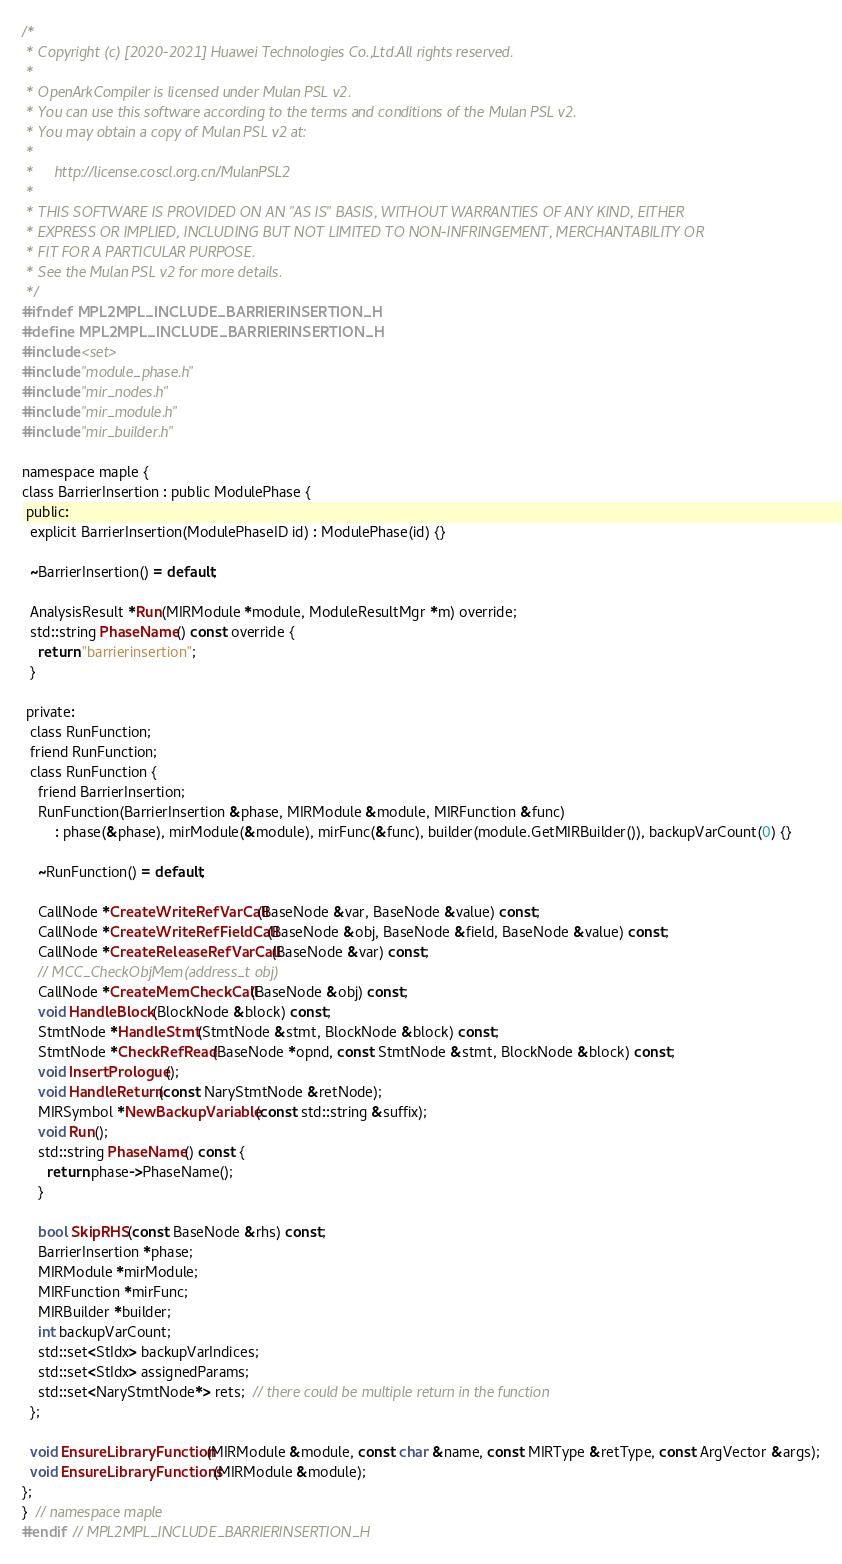<code> <loc_0><loc_0><loc_500><loc_500><_C_>/*
 * Copyright (c) [2020-2021] Huawei Technologies Co.,Ltd.All rights reserved.
 *
 * OpenArkCompiler is licensed under Mulan PSL v2.
 * You can use this software according to the terms and conditions of the Mulan PSL v2.
 * You may obtain a copy of Mulan PSL v2 at:
 *
 *     http://license.coscl.org.cn/MulanPSL2
 *
 * THIS SOFTWARE IS PROVIDED ON AN "AS IS" BASIS, WITHOUT WARRANTIES OF ANY KIND, EITHER
 * EXPRESS OR IMPLIED, INCLUDING BUT NOT LIMITED TO NON-INFRINGEMENT, MERCHANTABILITY OR
 * FIT FOR A PARTICULAR PURPOSE.
 * See the Mulan PSL v2 for more details.
 */
#ifndef MPL2MPL_INCLUDE_BARRIERINSERTION_H
#define MPL2MPL_INCLUDE_BARRIERINSERTION_H
#include <set>
#include "module_phase.h"
#include "mir_nodes.h"
#include "mir_module.h"
#include "mir_builder.h"

namespace maple {
class BarrierInsertion : public ModulePhase {
 public:
  explicit BarrierInsertion(ModulePhaseID id) : ModulePhase(id) {}

  ~BarrierInsertion() = default;

  AnalysisResult *Run(MIRModule *module, ModuleResultMgr *m) override;
  std::string PhaseName() const override {
    return "barrierinsertion";
  }

 private:
  class RunFunction;
  friend RunFunction;
  class RunFunction {
    friend BarrierInsertion;
    RunFunction(BarrierInsertion &phase, MIRModule &module, MIRFunction &func)
        : phase(&phase), mirModule(&module), mirFunc(&func), builder(module.GetMIRBuilder()), backupVarCount(0) {}

    ~RunFunction() = default;

    CallNode *CreateWriteRefVarCall(BaseNode &var, BaseNode &value) const;
    CallNode *CreateWriteRefFieldCall(BaseNode &obj, BaseNode &field, BaseNode &value) const;
    CallNode *CreateReleaseRefVarCall(BaseNode &var) const;
    // MCC_CheckObjMem(address_t obj)
    CallNode *CreateMemCheckCall(BaseNode &obj) const;
    void HandleBlock(BlockNode &block) const;
    StmtNode *HandleStmt(StmtNode &stmt, BlockNode &block) const;
    StmtNode *CheckRefRead(BaseNode *opnd, const StmtNode &stmt, BlockNode &block) const;
    void InsertPrologue();
    void HandleReturn(const NaryStmtNode &retNode);
    MIRSymbol *NewBackupVariable(const std::string &suffix);
    void Run();
    std::string PhaseName() const {
      return phase->PhaseName();
    }

    bool SkipRHS(const BaseNode &rhs) const;
    BarrierInsertion *phase;
    MIRModule *mirModule;
    MIRFunction *mirFunc;
    MIRBuilder *builder;
    int backupVarCount;
    std::set<StIdx> backupVarIndices;
    std::set<StIdx> assignedParams;
    std::set<NaryStmtNode*> rets;  // there could be multiple return in the function
  };

  void EnsureLibraryFunction(MIRModule &module, const char &name, const MIRType &retType, const ArgVector &args);
  void EnsureLibraryFunctions(MIRModule &module);
};
}  // namespace maple
#endif  // MPL2MPL_INCLUDE_BARRIERINSERTION_H
</code> 